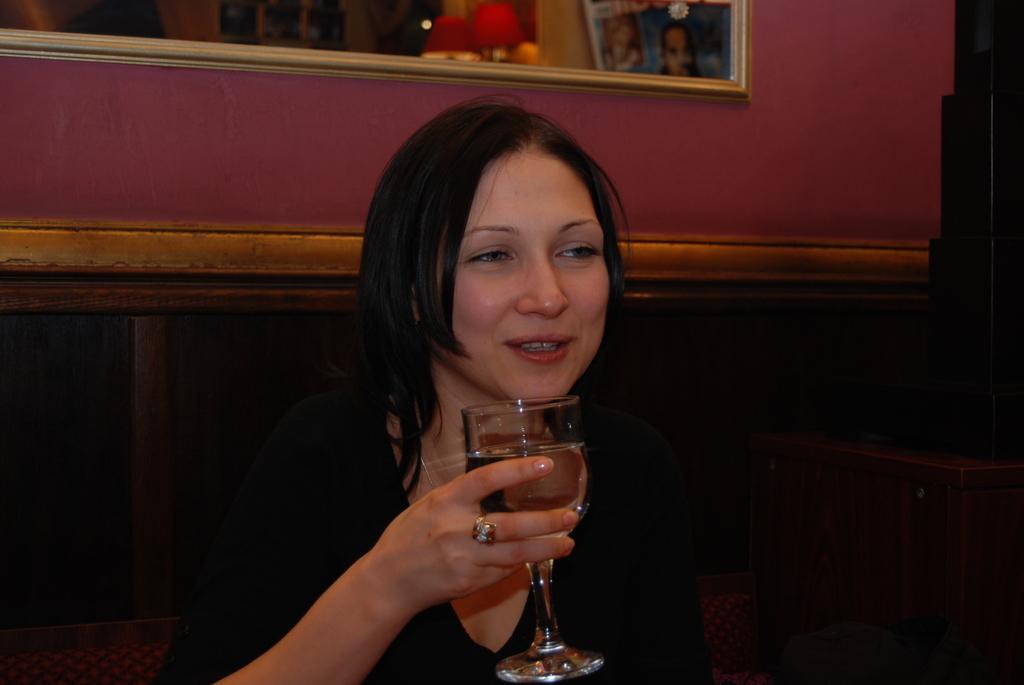Could you give a brief overview of what you see in this image? a person is wearing black dress and holding a glass in her hand. behind her there is a photo frame on the wall. 